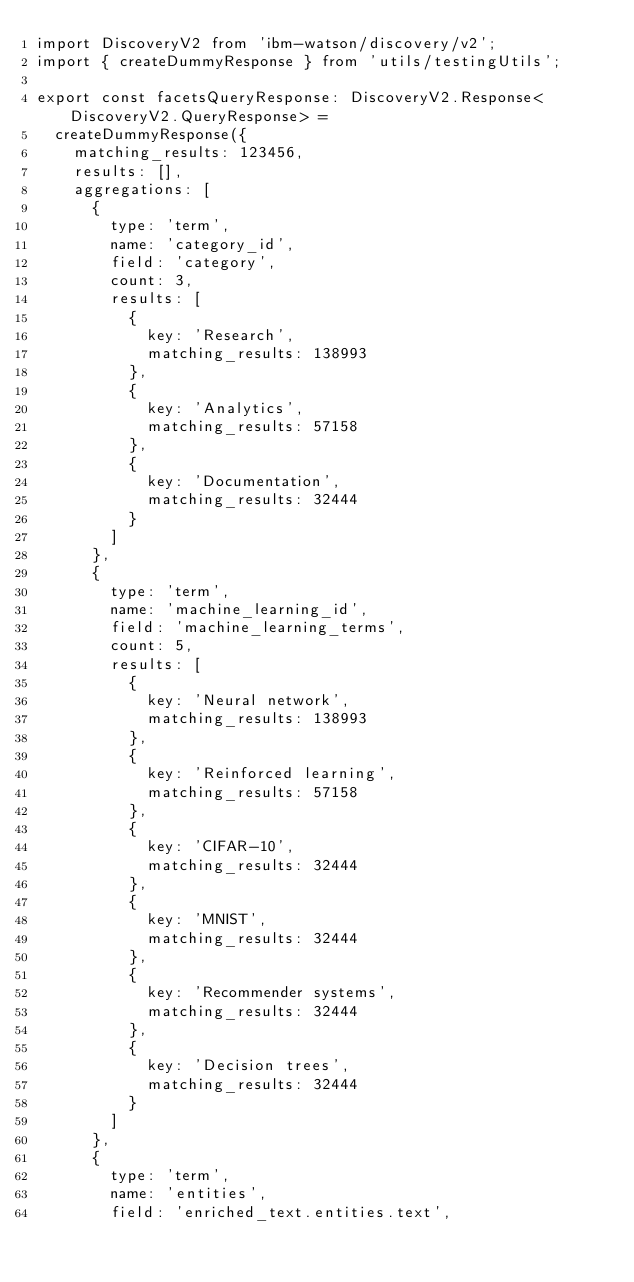Convert code to text. <code><loc_0><loc_0><loc_500><loc_500><_TypeScript_>import DiscoveryV2 from 'ibm-watson/discovery/v2';
import { createDummyResponse } from 'utils/testingUtils';

export const facetsQueryResponse: DiscoveryV2.Response<DiscoveryV2.QueryResponse> =
  createDummyResponse({
    matching_results: 123456,
    results: [],
    aggregations: [
      {
        type: 'term',
        name: 'category_id',
        field: 'category',
        count: 3,
        results: [
          {
            key: 'Research',
            matching_results: 138993
          },
          {
            key: 'Analytics',
            matching_results: 57158
          },
          {
            key: 'Documentation',
            matching_results: 32444
          }
        ]
      },
      {
        type: 'term',
        name: 'machine_learning_id',
        field: 'machine_learning_terms',
        count: 5,
        results: [
          {
            key: 'Neural network',
            matching_results: 138993
          },
          {
            key: 'Reinforced learning',
            matching_results: 57158
          },
          {
            key: 'CIFAR-10',
            matching_results: 32444
          },
          {
            key: 'MNIST',
            matching_results: 32444
          },
          {
            key: 'Recommender systems',
            matching_results: 32444
          },
          {
            key: 'Decision trees',
            matching_results: 32444
          }
        ]
      },
      {
        type: 'term',
        name: 'entities',
        field: 'enriched_text.entities.text',</code> 